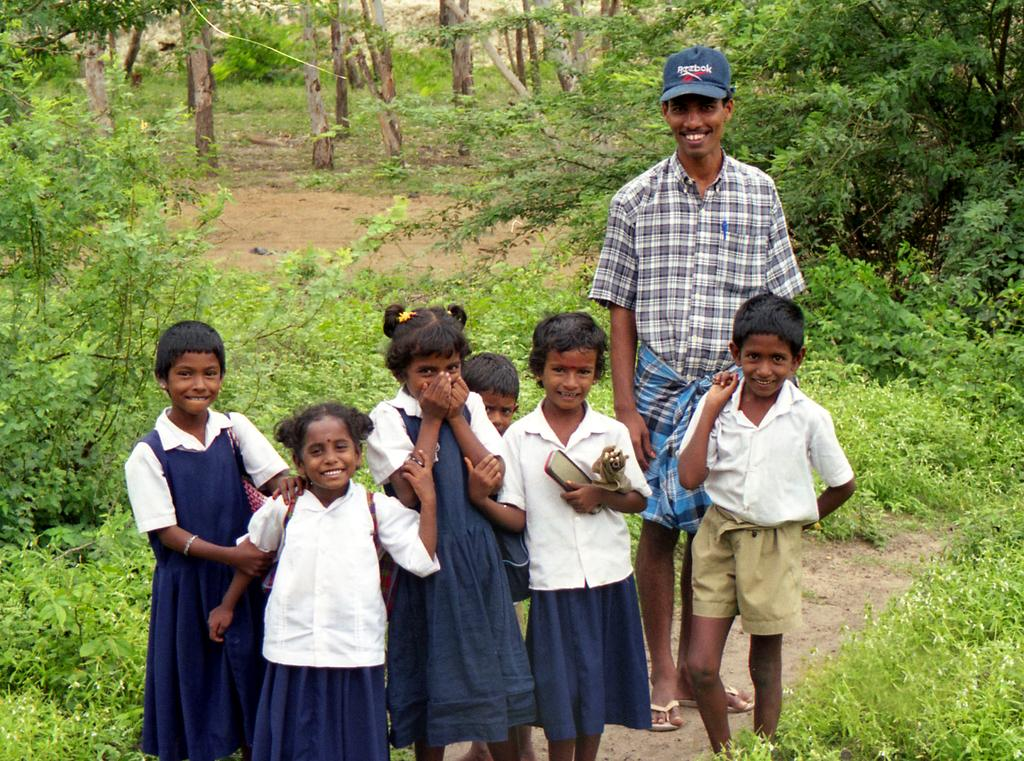What can be seen at the bottom of the image? There is a group of persons standing at the bottom of the image. What is visible in the background of the image? There are trees and plants in the background of the image. What type of skin is visible on the trees in the image? The trees in the image do not have skin; they have bark. Can you see any bun-related items in the image? There is no mention of a bun or any bun-related items in the image. 